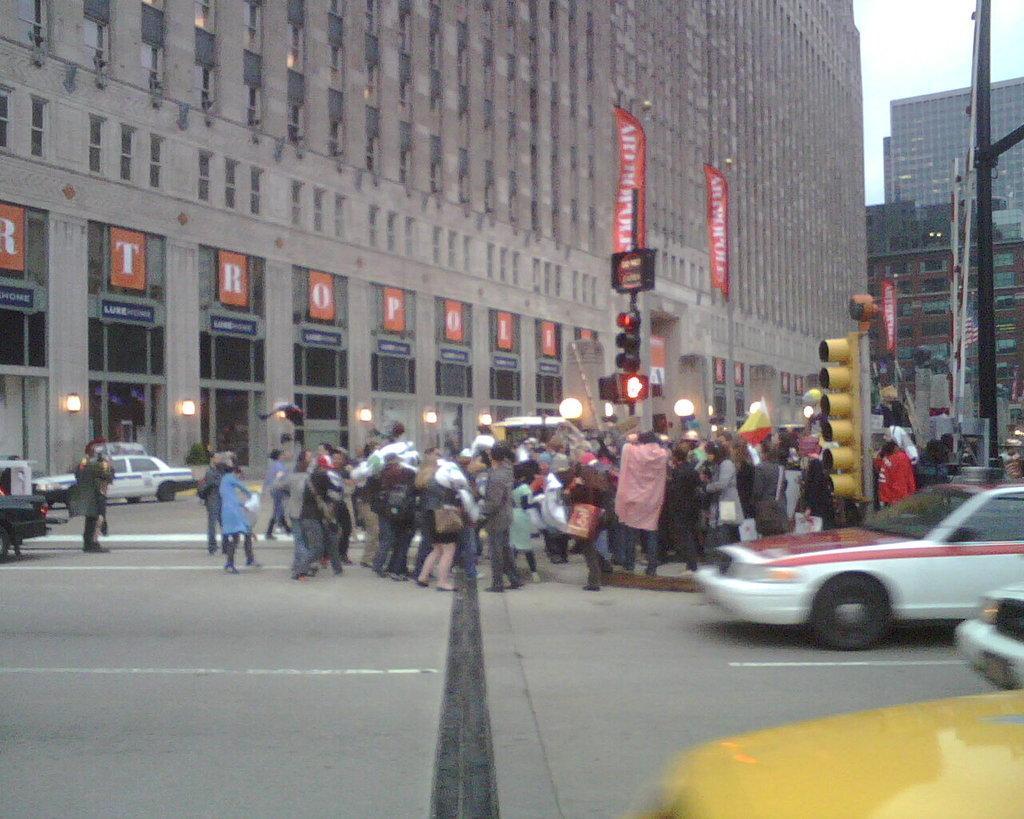Can you describe this image briefly? In front of the image there are cars on the road. Beside the road there are lights, traffic signals. In the center of the image there are people standing on the road. In the background there are buildings and sky. 